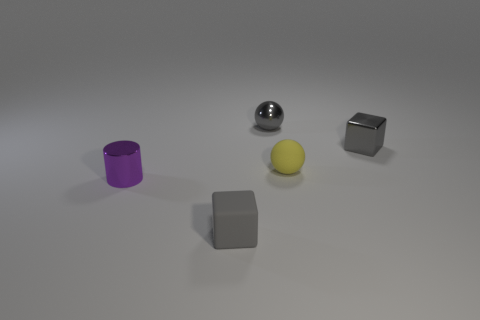Add 3 blue shiny cylinders. How many objects exist? 8 Subtract all blocks. How many objects are left? 3 Add 3 small metal objects. How many small metal objects are left? 6 Add 2 tiny gray matte cubes. How many tiny gray matte cubes exist? 3 Subtract 0 green spheres. How many objects are left? 5 Subtract all rubber cubes. Subtract all gray things. How many objects are left? 1 